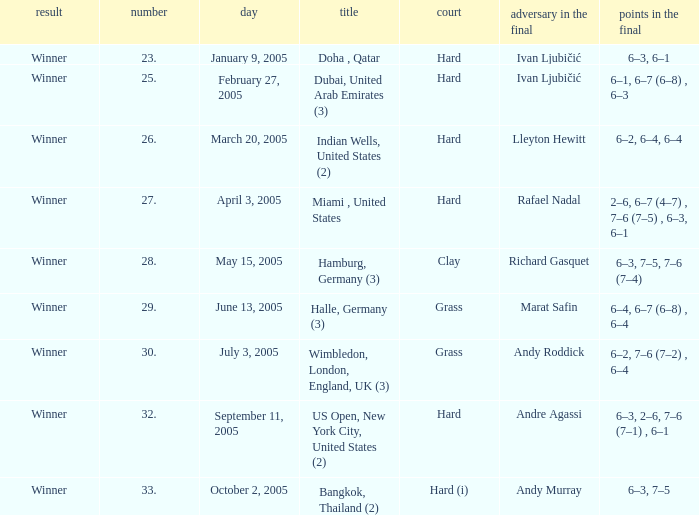How many championships are there on the date January 9, 2005? 1.0. 